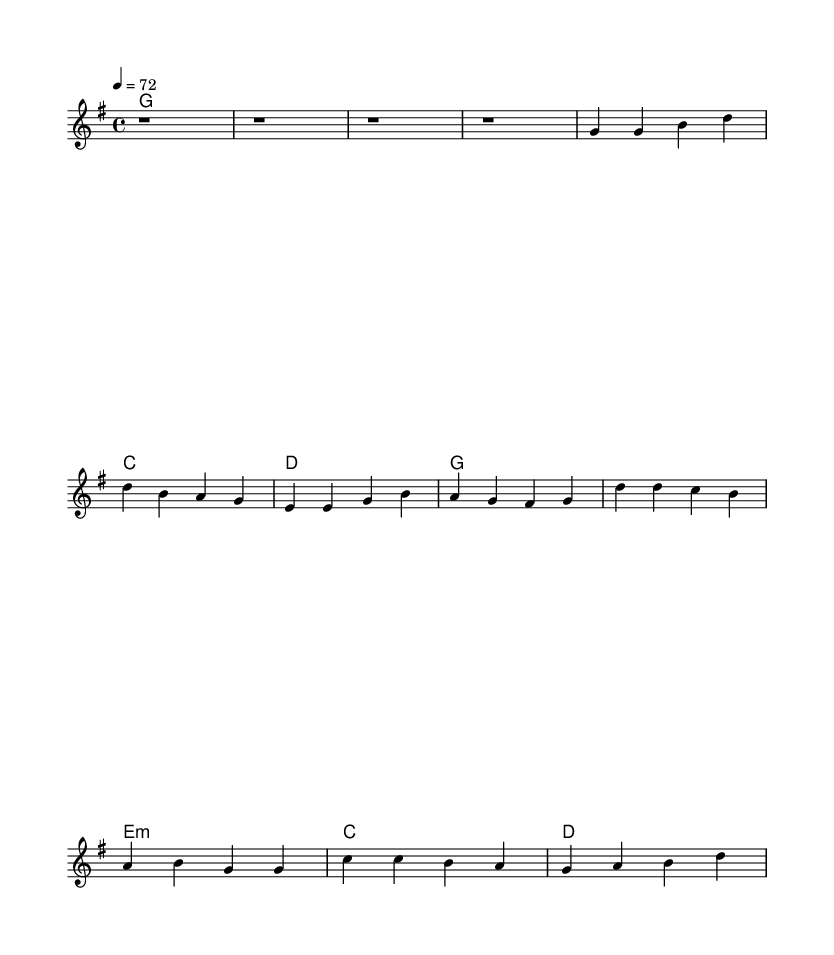What is the key signature of this music? The key signature is G major, which contains one sharp (F#). This can be identified by looking at the key signature indicator at the beginning of the score.
Answer: G major What is the time signature of this music? The time signature is 4/4, which is indicated at the beginning of the score. It means there are four beats in a measure and the quarter note gets one beat.
Answer: 4/4 What is the tempo marking for this piece? The tempo marking is indicated as "4 = 72," which means that the quarter note should be played at a rate of 72 beats per minute. This indicates a moderate pace for the music.
Answer: 72 How many measures are there in the verse section? The verse section consists of four measures, as shown by the melodic rhythm that includes four rhythmic patterns under the verse heading.
Answer: 4 What is the primary chord used in the introduction? The primary chord used in the introduction is G major, as indicated by the chord names above the melody line in the score.
Answer: G major What type of chord is used in the chorus before the last measure? The chord used in the chorus before the last measure is E minor, which can be identified as it appears in the chord line at the beginning of the chorus.
Answer: E minor What kind of musical atmosphere does this piece likely evoke? This piece likely evokes a nostalgic and communal atmosphere, which is typical for country rock ballads celebrating small-town life. The combination of chords and melodic line supports this sentiment.
Answer: Nostalgic 